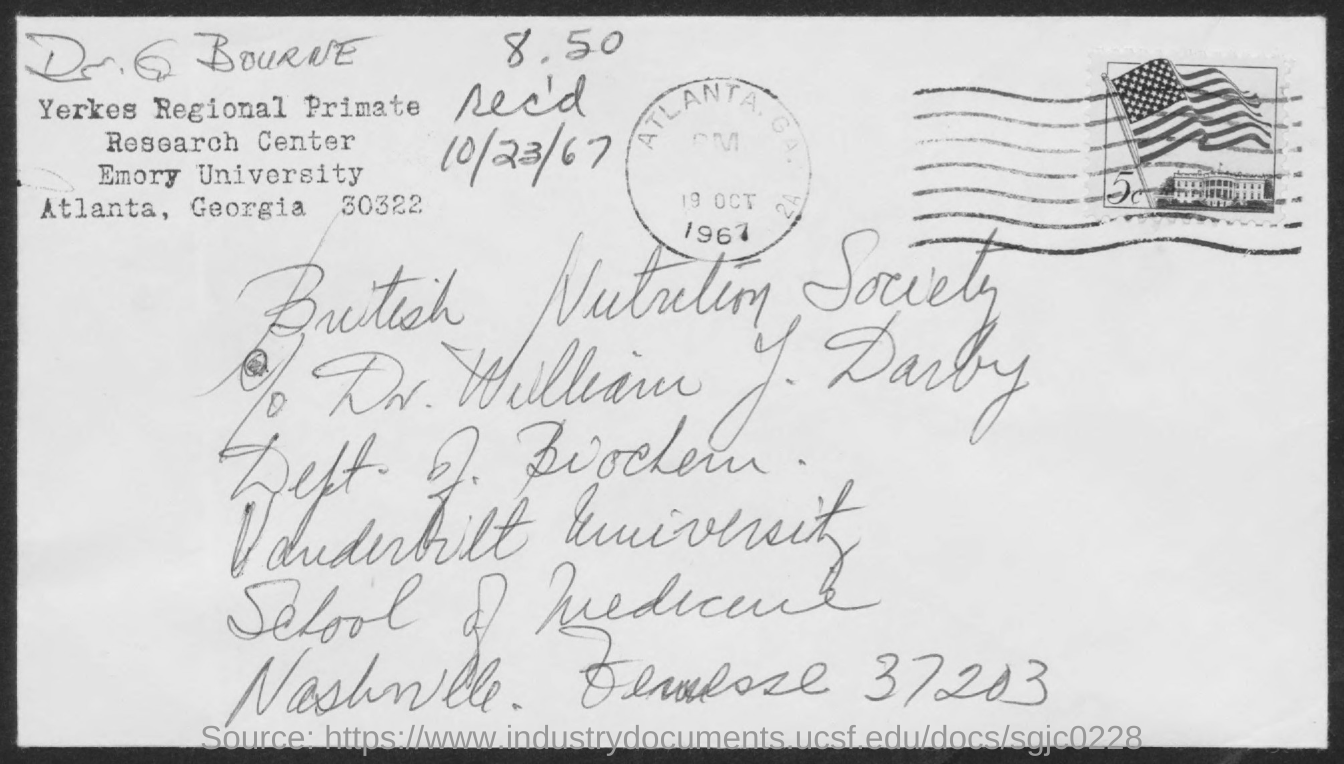Point out several critical features in this image. The received date mentioned in the postal card is October 23, 1967. 